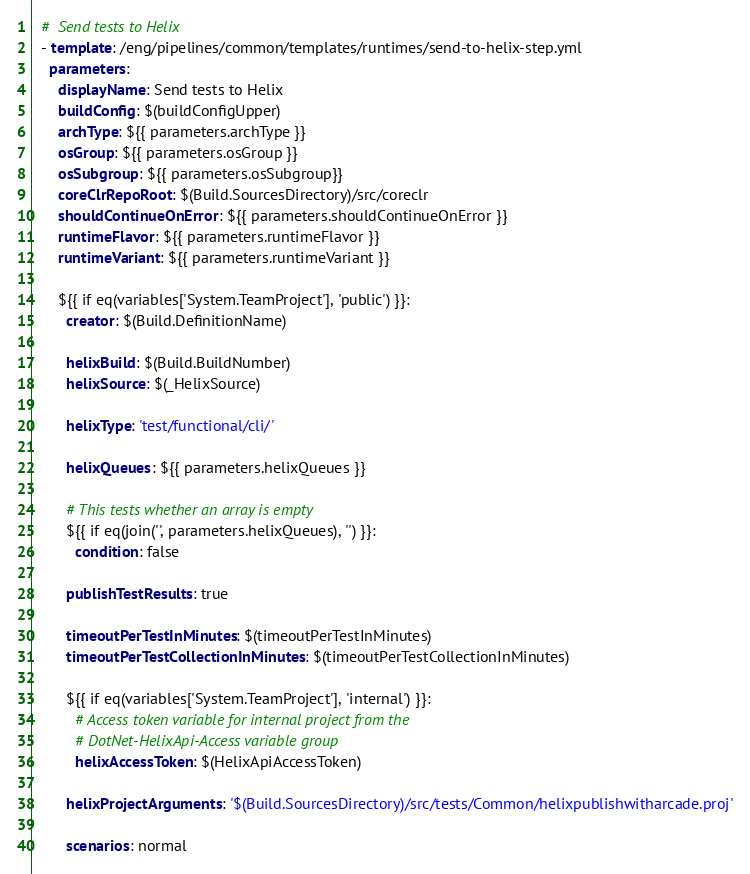Convert code to text. <code><loc_0><loc_0><loc_500><loc_500><_YAML_>  #  Send tests to Helix
  - template: /eng/pipelines/common/templates/runtimes/send-to-helix-step.yml
    parameters:
      displayName: Send tests to Helix
      buildConfig: $(buildConfigUpper)
      archType: ${{ parameters.archType }}
      osGroup: ${{ parameters.osGroup }}
      osSubgroup: ${{ parameters.osSubgroup}}
      coreClrRepoRoot: $(Build.SourcesDirectory)/src/coreclr
      shouldContinueOnError: ${{ parameters.shouldContinueOnError }}
      runtimeFlavor: ${{ parameters.runtimeFlavor }}
      runtimeVariant: ${{ parameters.runtimeVariant }}

      ${{ if eq(variables['System.TeamProject'], 'public') }}:
        creator: $(Build.DefinitionName)

        helixBuild: $(Build.BuildNumber)
        helixSource: $(_HelixSource)

        helixType: 'test/functional/cli/'

        helixQueues: ${{ parameters.helixQueues }}

        # This tests whether an array is empty
        ${{ if eq(join('', parameters.helixQueues), '') }}:
          condition: false

        publishTestResults: true

        timeoutPerTestInMinutes: $(timeoutPerTestInMinutes)
        timeoutPerTestCollectionInMinutes: $(timeoutPerTestCollectionInMinutes)

        ${{ if eq(variables['System.TeamProject'], 'internal') }}:
          # Access token variable for internal project from the
          # DotNet-HelixApi-Access variable group
          helixAccessToken: $(HelixApiAccessToken)

        helixProjectArguments: '$(Build.SourcesDirectory)/src/tests/Common/helixpublishwitharcade.proj'

        scenarios: normal </code> 